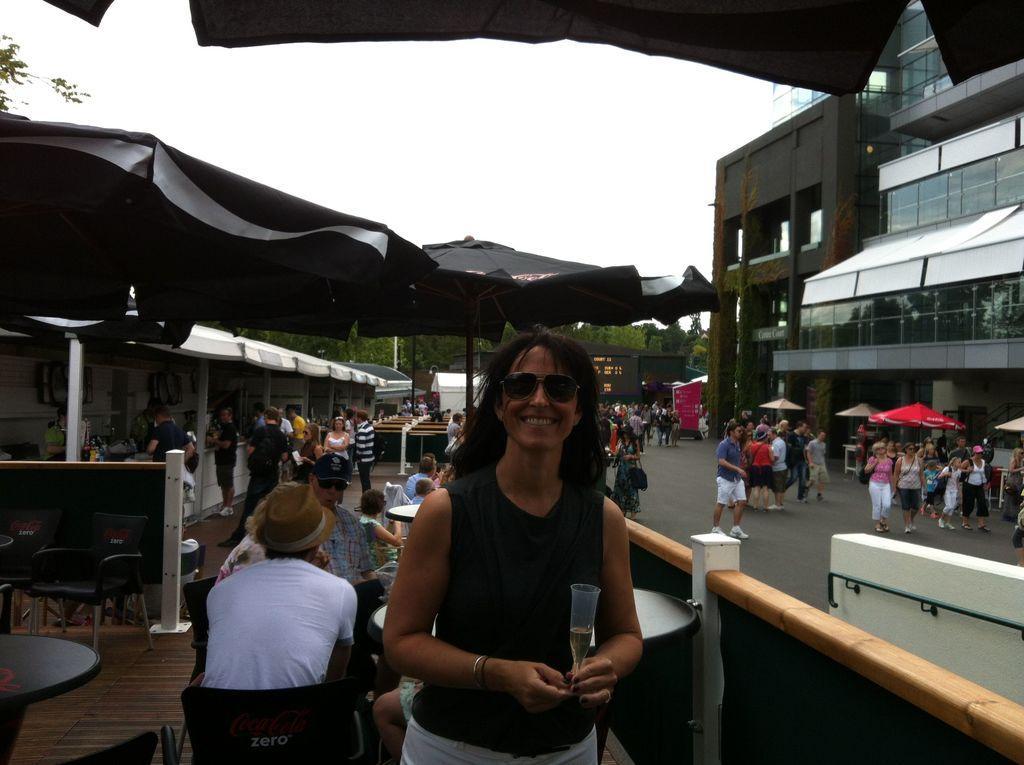Can you describe this image briefly? In the picture we can see a woman standing in a black top and holding a glass with a liquid in it and behind her we can see some people are sitting near the tables and behind them, we can see some stalls and some people are standing near it and opposite side of it we can see the building and some people are walking near it and in the background we can see the sky. 